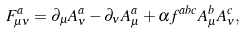Convert formula to latex. <formula><loc_0><loc_0><loc_500><loc_500>F ^ { a } _ { \mu \nu } = \partial _ { \mu } A ^ { a } _ { \nu } - \partial _ { \nu } A ^ { a } _ { \mu } + \alpha f ^ { a b c } A ^ { b } _ { \mu } A ^ { c } _ { \nu } ,</formula> 